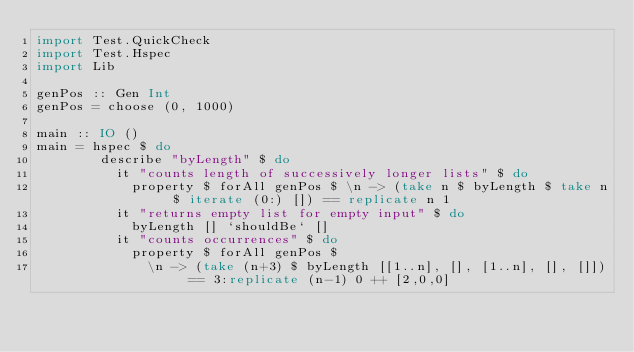Convert code to text. <code><loc_0><loc_0><loc_500><loc_500><_Haskell_>import Test.QuickCheck
import Test.Hspec 
import Lib

genPos :: Gen Int
genPos = choose (0, 1000)

main :: IO ()
main = hspec $ do
        describe "byLength" $ do
          it "counts length of successively longer lists" $ do
            property $ forAll genPos $ \n -> (take n $ byLength $ take n $ iterate (0:) []) == replicate n 1
          it "returns empty list for empty input" $ do
            byLength [] `shouldBe` []
          it "counts occurrences" $ do
            property $ forAll genPos $
              \n -> (take (n+3) $ byLength [[1..n], [], [1..n], [], []]) == 3:replicate (n-1) 0 ++ [2,0,0]
</code> 